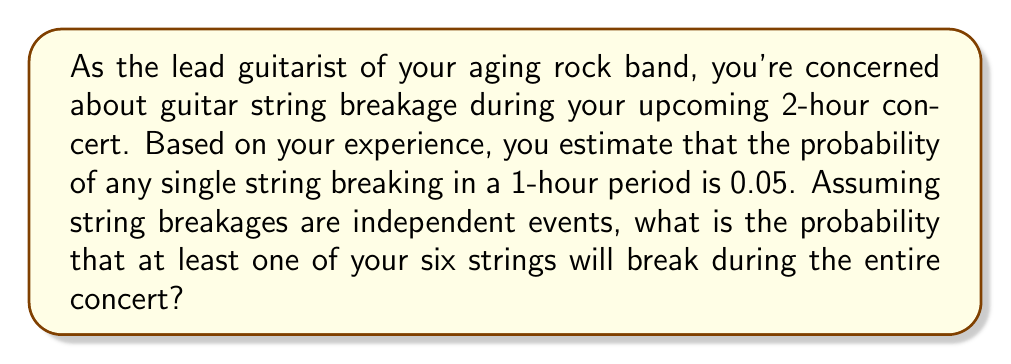Can you solve this math problem? Let's approach this step-by-step:

1) First, we need to calculate the probability of a single string not breaking during the 2-hour concert.

   For a 1-hour period: $P(\text{string not breaking}) = 1 - 0.05 = 0.95$
   
   For a 2-hour period: $P(\text{string not breaking for 2 hours}) = 0.95^2 = 0.9025$

2) Now, for all six strings to not break, each string must not break. Since these are independent events, we multiply the probabilities:

   $P(\text{no strings break}) = (0.9025)^6 = 0.5645$

3) The probability of at least one string breaking is the complement of no strings breaking:

   $P(\text{at least one string breaks}) = 1 - P(\text{no strings break})$
   
   $= 1 - 0.5645 = 0.4355$

4) To express this as a percentage:

   $0.4355 \times 100\% = 43.55\%$

Thus, there is a 43.55% chance that at least one string will break during your 2-hour concert.
Answer: 43.55% 